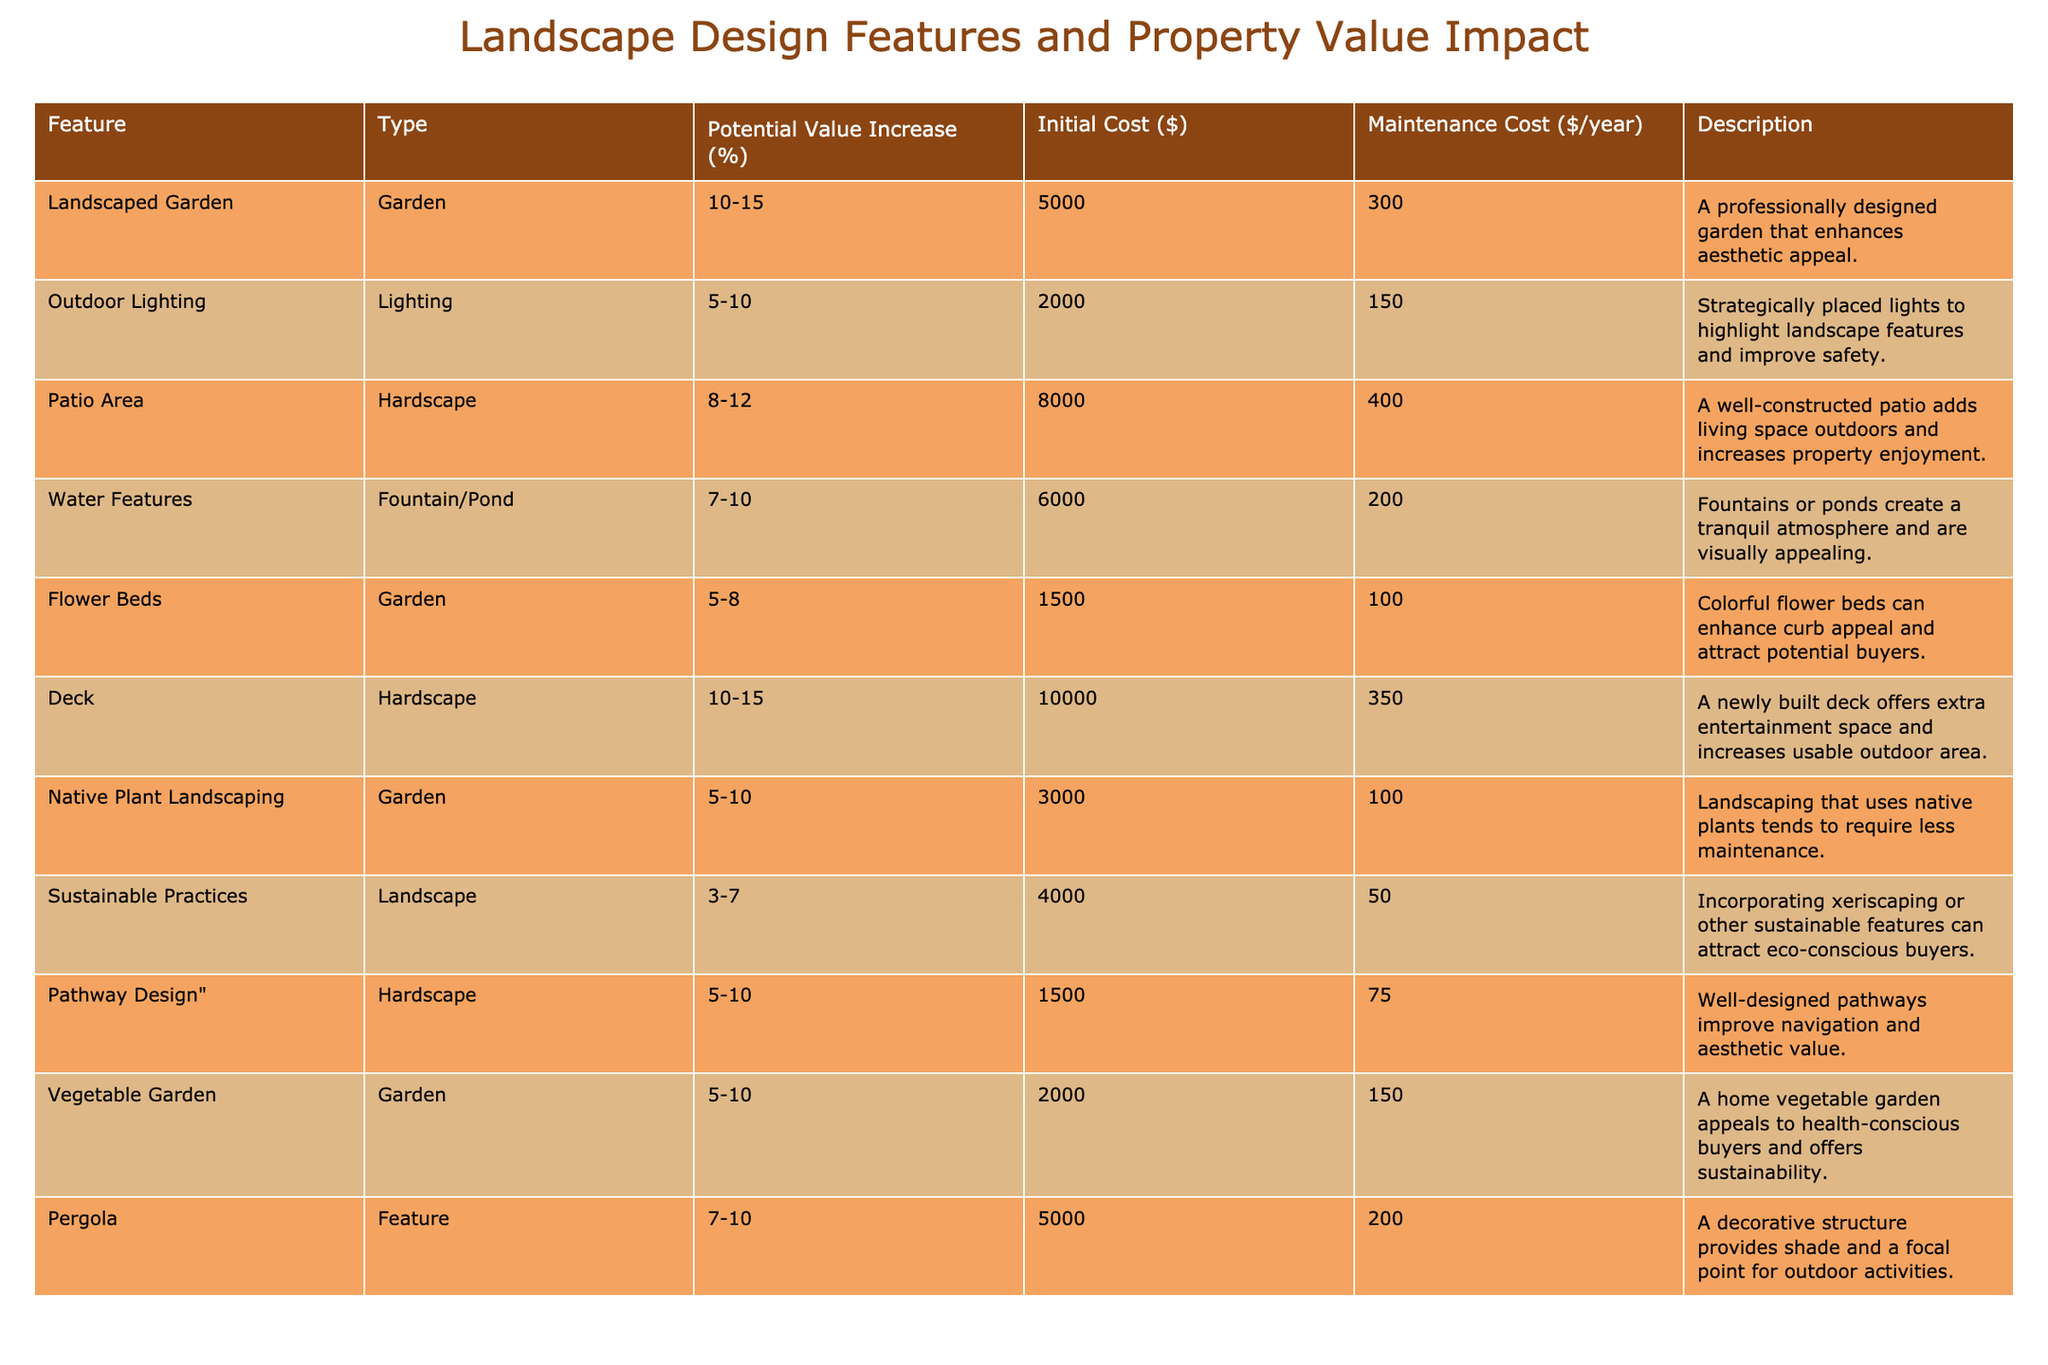What is the potential value increase range for a landscaped garden? The table shows that the potential value increase for a landscaped garden is between 10% and 15%.
Answer: 10-15% Which feature has the highest initial cost? The deck has the highest initial cost of $10,000, according to the table.
Answer: $10,000 What is the average maintenance cost for flower beds and vegetable gardens combined? The maintenance costs for flower beds and vegetable gardens are $100 and $150, respectively. Their sum is $250, and the average is $250/2 = $125.
Answer: $125 Is the potential value increase for outdoor lighting higher than 10%? The potential value increase range for outdoor lighting is between 5% and 10%, so it cannot exceed 10%.
Answer: No Which feature has a potential value increase of 7-10%? The features listed with a potential value increase of 7-10% are water features and pergolas.
Answer: Water features and pergolas If I add both a patio area and a deck, what is the potential value increase range? The patio area has an increase of 8-12% and the deck has 10-15%. The combined range minimum is 8%, and maximum is 15%, leading to a new range of 8-15%.
Answer: 8-15% How much does sustainable practices cost in terms of initial investment? The initial cost for sustainable practices listed in the table is $4,000.
Answer: $4,000 Is the maintenance cost for pathways higher than that for flower beds? The maintenance cost for pathways is $75, while for flower beds it is $100. Therefore, the cost for flower beds is higher.
Answer: No What is the total initial cost if I choose to implement both outdoor lighting and a vegetable garden? The initial costs are $2,000 for outdoor lighting and $2,000 for a vegetable garden, totaling $4,000.
Answer: $4,000 Which landscape feature requires the least maintenance cost per year? The sustainable practices feature requires the least maintenance cost at $50 per year, as shown in the table.
Answer: $50 